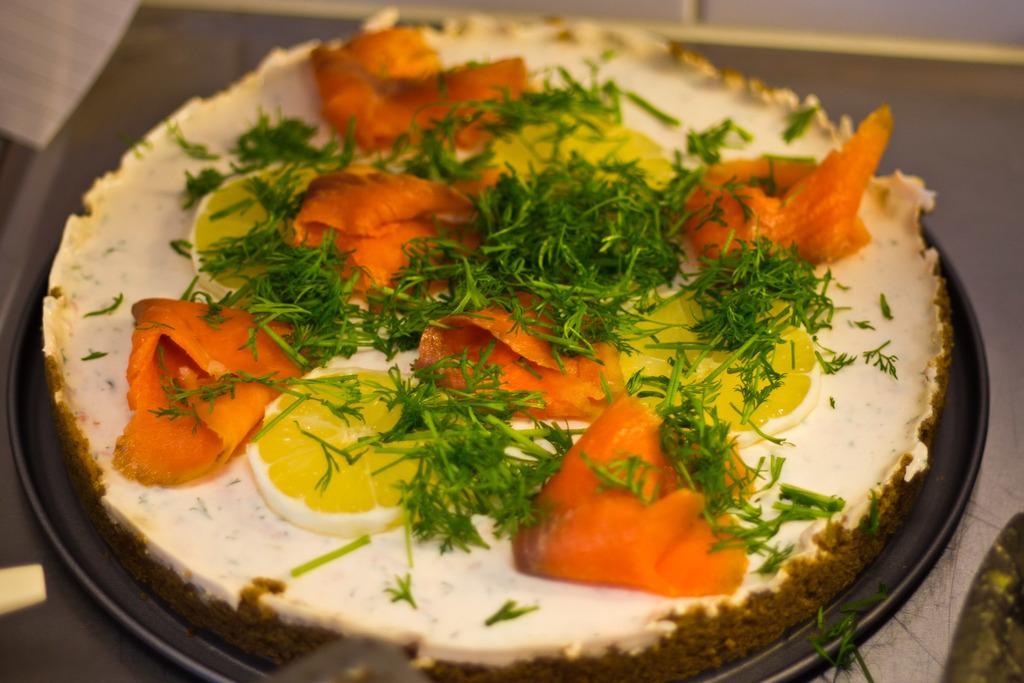Describe this image in one or two sentences. In this image I can see a pan which consists of some food item. The background is blurred. This food item is garnished with some leaves and lemon slices. 